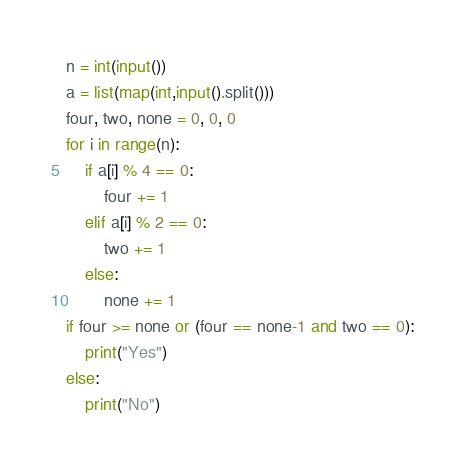<code> <loc_0><loc_0><loc_500><loc_500><_Python_>n = int(input())
a = list(map(int,input().split()))
four, two, none = 0, 0, 0
for i in range(n):
    if a[i] % 4 == 0:
        four += 1
    elif a[i] % 2 == 0:
        two += 1
    else:
        none += 1
if four >= none or (four == none-1 and two == 0):
    print("Yes")
else:
    print("No")</code> 